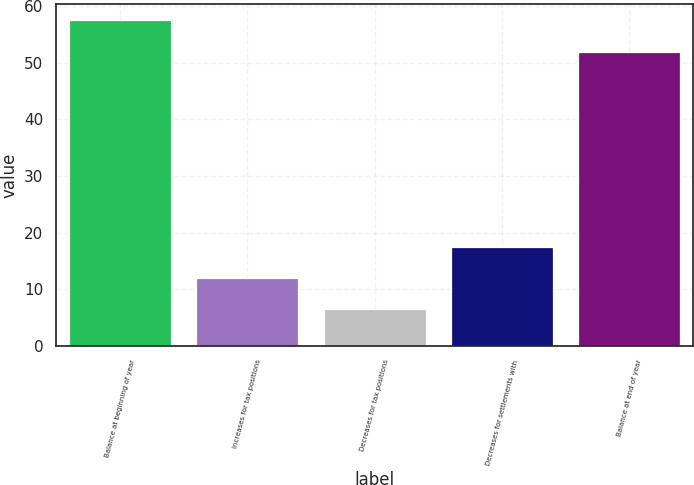Convert chart to OTSL. <chart><loc_0><loc_0><loc_500><loc_500><bar_chart><fcel>Balance at beginning of year<fcel>Increases for tax positions<fcel>Decreases for tax positions<fcel>Decreases for settlements with<fcel>Balance at end of year<nl><fcel>57.5<fcel>12<fcel>6.5<fcel>17.5<fcel>52<nl></chart> 